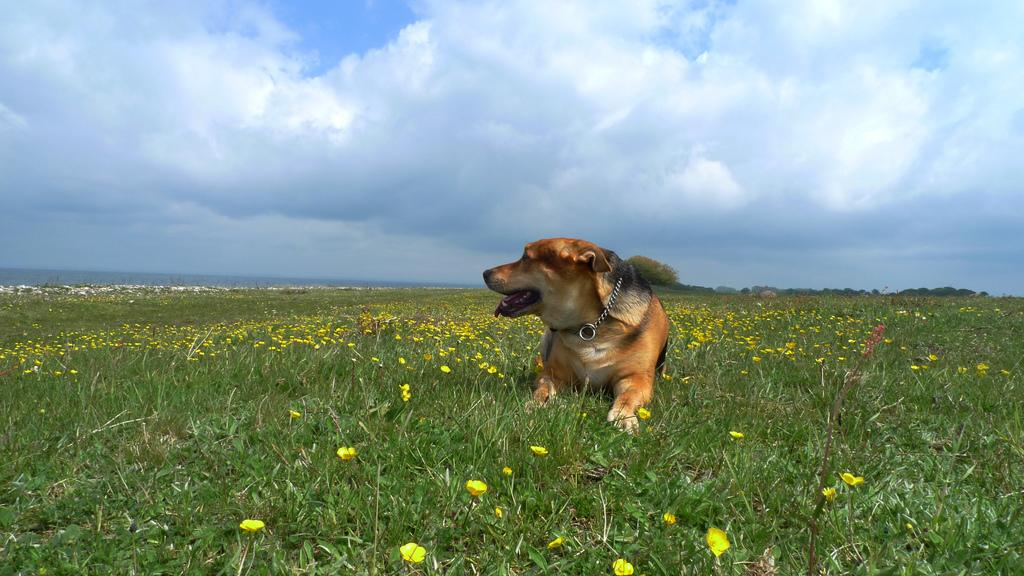What type of animal is in the image? There is a dog in the image. What is at the bottom of the image? There is grass and flowers at the bottom of the image. What can be seen in the background of the image? The sky is visible in the background of the image, and there are clouds present. What is the shape of the lake in the image? There is no lake present in the image. 